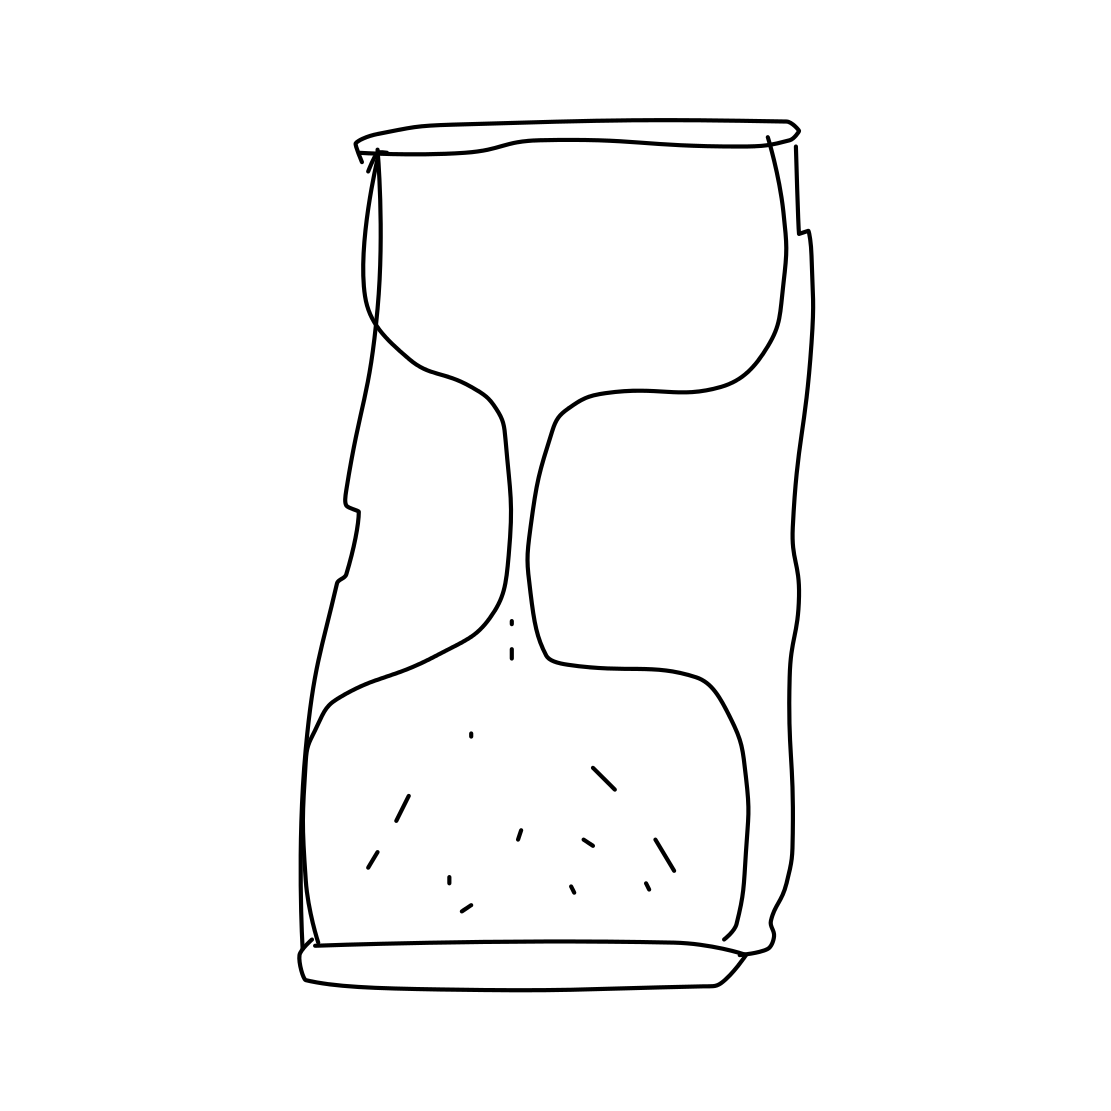Is there a sketchy teacup in the picture? Upon closely examining the drawing, we can confirm that there is no sketchy teacup present in the picture. Instead, the image portrays an abstract, contoured drawing that resembles a deformed can or a cylindrical shape with irregular edges, not characteristic of a teacup. 